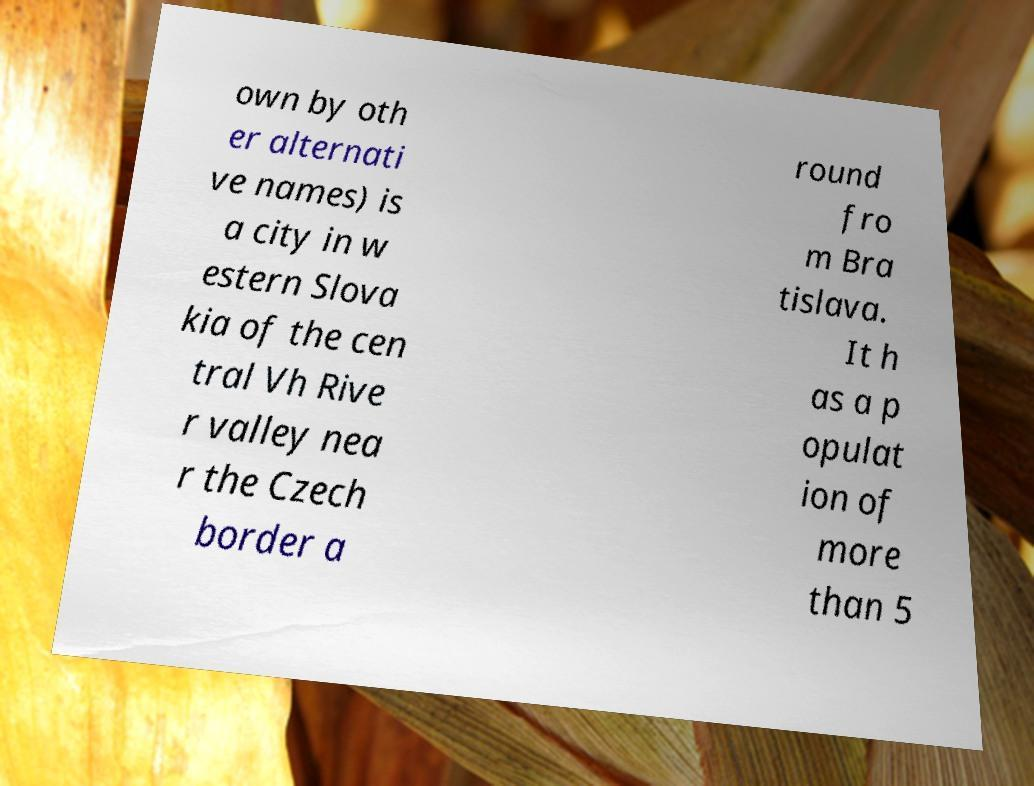Can you read and provide the text displayed in the image?This photo seems to have some interesting text. Can you extract and type it out for me? own by oth er alternati ve names) is a city in w estern Slova kia of the cen tral Vh Rive r valley nea r the Czech border a round fro m Bra tislava. It h as a p opulat ion of more than 5 